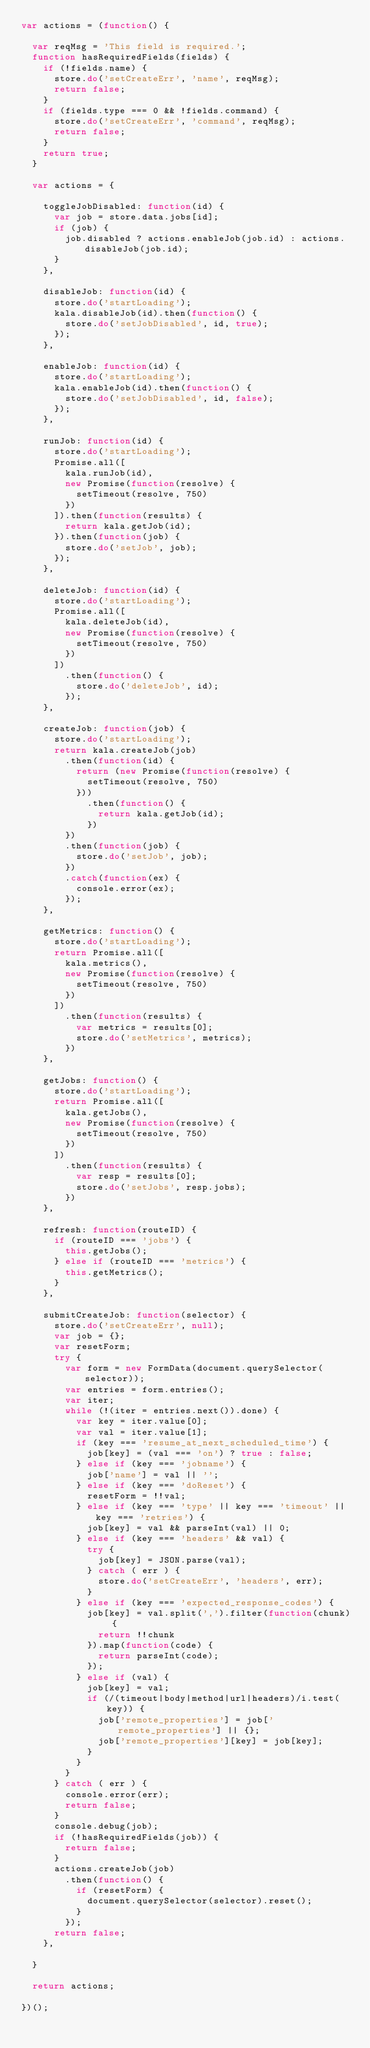Convert code to text. <code><loc_0><loc_0><loc_500><loc_500><_JavaScript_>var actions = (function() {

  var reqMsg = 'This field is required.';
  function hasRequiredFields(fields) {
    if (!fields.name) {
      store.do('setCreateErr', 'name', reqMsg);
      return false;
    }
    if (fields.type === 0 && !fields.command) {
      store.do('setCreateErr', 'command', reqMsg);
      return false;
    }
    return true;
  }

  var actions = {

    toggleJobDisabled: function(id) {
      var job = store.data.jobs[id];
      if (job) {
        job.disabled ? actions.enableJob(job.id) : actions.disableJob(job.id);
      }
    },

    disableJob: function(id) {
      store.do('startLoading');
      kala.disableJob(id).then(function() {
        store.do('setJobDisabled', id, true);
      });
    },

    enableJob: function(id) {
      store.do('startLoading');
      kala.enableJob(id).then(function() {
        store.do('setJobDisabled', id, false);
      });
    },

    runJob: function(id) {
      store.do('startLoading');
      Promise.all([
        kala.runJob(id),
        new Promise(function(resolve) {
          setTimeout(resolve, 750)
        })
      ]).then(function(results) {
        return kala.getJob(id);
      }).then(function(job) {
        store.do('setJob', job);
      });
    },

    deleteJob: function(id) {
      store.do('startLoading');
      Promise.all([
        kala.deleteJob(id),
        new Promise(function(resolve) {
          setTimeout(resolve, 750)
        })
      ])
        .then(function() {
          store.do('deleteJob', id);
        });
    },

    createJob: function(job) {
      store.do('startLoading');
      return kala.createJob(job)
        .then(function(id) {
          return (new Promise(function(resolve) {
            setTimeout(resolve, 750)
          }))
            .then(function() {
              return kala.getJob(id);
            })
        })
        .then(function(job) {
          store.do('setJob', job);
        })
        .catch(function(ex) {
          console.error(ex);
        });
    },

    getMetrics: function() {
      store.do('startLoading');
      return Promise.all([
        kala.metrics(),
        new Promise(function(resolve) {
          setTimeout(resolve, 750)
        })
      ])
        .then(function(results) {
          var metrics = results[0];
          store.do('setMetrics', metrics);
        })
    },

    getJobs: function() {
      store.do('startLoading');
      return Promise.all([
        kala.getJobs(),
        new Promise(function(resolve) {
          setTimeout(resolve, 750)
        })
      ])
        .then(function(results) {
          var resp = results[0];
          store.do('setJobs', resp.jobs);
        })
    },

    refresh: function(routeID) {
      if (routeID === 'jobs') {
        this.getJobs();
      } else if (routeID === 'metrics') {
        this.getMetrics();
      }
    },

    submitCreateJob: function(selector) {
      store.do('setCreateErr', null);
      var job = {};
      var resetForm;
      try {
        var form = new FormData(document.querySelector(selector));
        var entries = form.entries();
        var iter;
        while (!(iter = entries.next()).done) {
          var key = iter.value[0];
          var val = iter.value[1];
          if (key === 'resume_at_next_scheduled_time') {
            job[key] = (val === 'on') ? true : false;
          } else if (key === 'jobname') {
            job['name'] = val || '';
          } else if (key === 'doReset') {
            resetForm = !!val;
          } else if (key === 'type' || key === 'timeout' || key === 'retries') {
            job[key] = val && parseInt(val) || 0;
          } else if (key === 'headers' && val) {
            try {
              job[key] = JSON.parse(val);
            } catch ( err ) {
              store.do('setCreateErr', 'headers', err);
            }
          } else if (key === 'expected_response_codes') {
            job[key] = val.split(',').filter(function(chunk) {
              return !!chunk
            }).map(function(code) {
              return parseInt(code);
            });
          } else if (val) {
            job[key] = val;
            if (/(timeout|body|method|url|headers)/i.test(key)) {
              job['remote_properties'] = job['remote_properties'] || {};
              job['remote_properties'][key] = job[key];
            }
          }
        }
      } catch ( err ) {
        console.error(err);
        return false;
      }
      console.debug(job);
      if (!hasRequiredFields(job)) {
        return false;
      }
      actions.createJob(job)
        .then(function() {
          if (resetForm) {
            document.querySelector(selector).reset();
          }
        });
      return false;
    },

  }

  return actions;

})();
</code> 